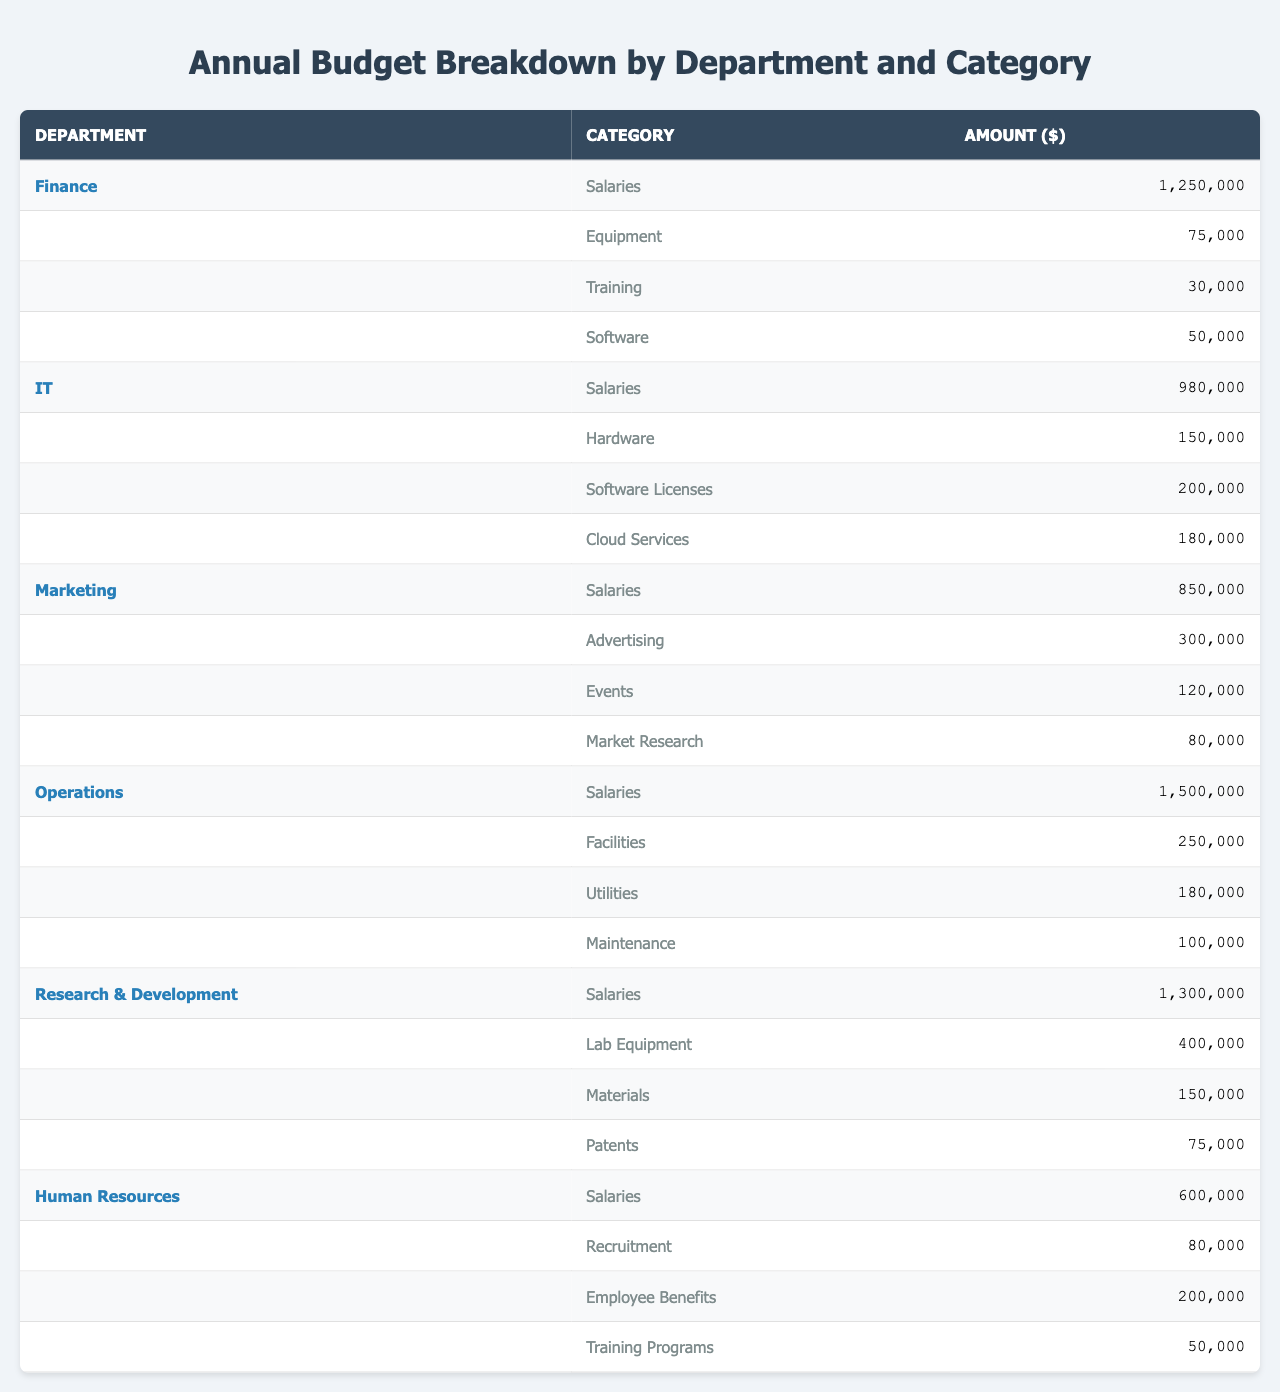What's the total budget allocated for the IT department? The table lists the budget categories for the IT department: Salaries ($980,000), Hardware ($150,000), Software Licenses ($200,000), and Cloud Services ($180,000). Summing these amounts gives $980,000 + $150,000 + $200,000 + $180,000 = $1,510,000.
Answer: $1,510,000 Which department has the highest salary expenditure? The salaries for each department are listed: Finance ($1,250,000), IT ($980,000), Marketing ($850,000), Operations ($1,500,000), Research & Development ($1,300,000), and Human Resources ($600,000). Comparing these values, Operations has the highest with $1,500,000.
Answer: Operations What is the total budget for Marketing's categories combined? Marketing has the following budget categories: Salaries ($850,000), Advertising ($300,000), Events ($120,000), and Market Research ($80,000). Adding these amounts: $850,000 + $300,000 + $120,000 + $80,000 = $1,350,000.
Answer: $1,350,000 Is the total amount spent on Salaries across all departments greater than $5,000,000? The salaries across departments are: Finance ($1,250,000), IT ($980,000), Marketing ($850,000), Operations ($1,500,000), Research & Development ($1,300,000), and Human Resources ($600,000). Summing these: $1,250,000 + $980,000 + $850,000 + $1,500,000 + $1,300,000 + $600,000 = $6,480,000, which is indeed greater than $5,000,000.
Answer: Yes What is the average budget spent on Equipment across departments? Only the Finance ($75,000) and IT ($150,000) departments have budget categories for Equipment. The average is calculated by adding these two amounts: $75,000 + $150,000 = $225,000, then dividing by 2, which gives $225,000 / 2 = $112,500.
Answer: $112,500 How much more is spent on Research & Development's Lab Equipment compared to Human Resources' Employee Benefits? The Lab Equipment expense for Research & Development is $400,000, and the Employee Benefits for Human Resources is $200,000. The difference is calculated as $400,000 - $200,000 = $200,000, meaning $200,000 more is spent on Lab Equipment.
Answer: $200,000 What is the total amount spent on Training across all departments? Reviewing the Training categories, we have: Finance ($30,000), Human Resources ($50,000) for Training Programs. Adding these amounts gives $30,000 + $50,000 = $80,000.
Answer: $80,000 Which department has the least amount spent on Advertising? Only Marketing has an Advertising expense of $300,000, while the other departments do not have this category listed; therefore, Marketing has the least (and only) expenditure in this category.
Answer: Marketing 